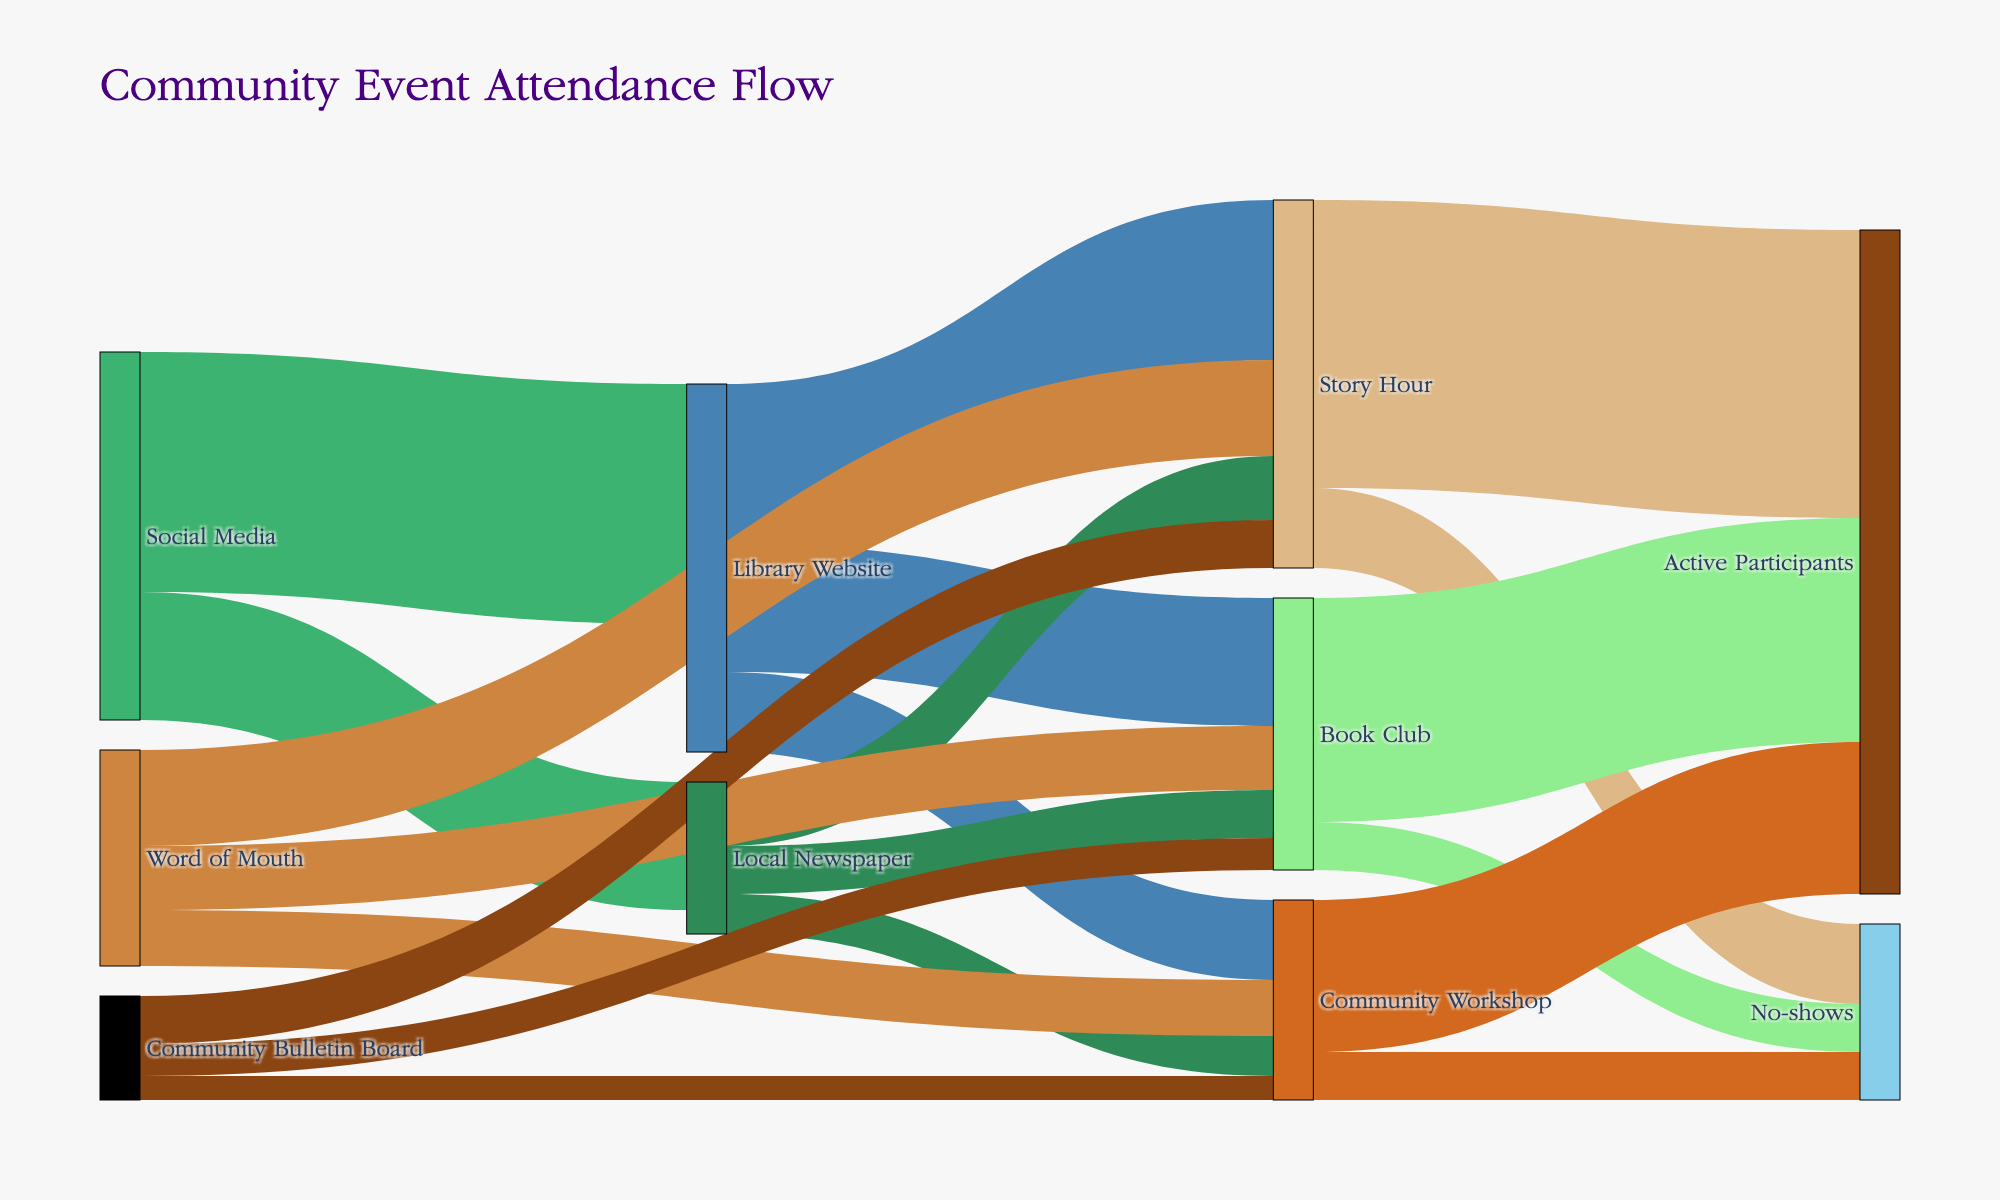What is the title of the Sankey Diagram? The title is displayed prominently at the top of the diagram and usually summarizes the content.
Answer: Community Event Attendance Flow How many active participants attended the Community Workshop event? The flow from “Community Workshop” to "Active Participants" indicates the number of active participants. According to the data, it is 95.
Answer: 95 Which promotional channel directed the most people to the Library Website? By examining the flows entering the Library Website, we see that Social Media directed 150 people, which is the highest among the channels.
Answer: Social Media What is the total number of no-shows across all events? Sum the no-shows for Story Hour (50), Book Club (30), and Community Workshop (30) from the diagram. Total = 50 + 30 + 30 = 110.
Answer: 110 Between Local Newspaper and Word of Mouth, which source directed more people to the Story Hour event? Compare the values of flows from Local Newspaper (40) and Word of Mouth (60) to Story Hour. Word of Mouth directed more people.
Answer: Word of Mouth How many people were directed to the Community Workshop event in total? Sum the values of flows to Community Workshop from Library Website (50), Local Newspaper (25), and Word of Mouth (35). Total = 50 + 25 + 35 = 110.
Answer: 110 Which event had the highest participation from attendees reached via the Library Website? Compare the flows from the Library Website to Story Hour (100), Book Club (80), and Community Workshop (50). Story Hour had the highest participation.
Answer: Story Hour If you sum all flows leading to "Active Participants," what is the total value? Sum the values of flows to "Active Participants" from Story Hour (180), Book Club (140), and Community Workshop (95). Total = 180 + 140 + 95 = 415.
Answer: 415 What percentage of the people directed to the Book Club event by the Library Website actually became active participants? The flow from Library Website to Book Club is 80, and from Book Club to Active Participants is 140, but since total Book Club participants are divided among initial sources, we consider 170 as the base: (140/170) * 100 = 82.35%.
Answer: 82.35% Compare the total number of participants (active and no-shows) for Story Hour and Book Club. Which had more? Sum the total for Story Hour (180 active + 50 no-shows = 230) and Book Club (140 active + 30 no-shows = 170). Story Hour had more participants.
Answer: Story Hour 